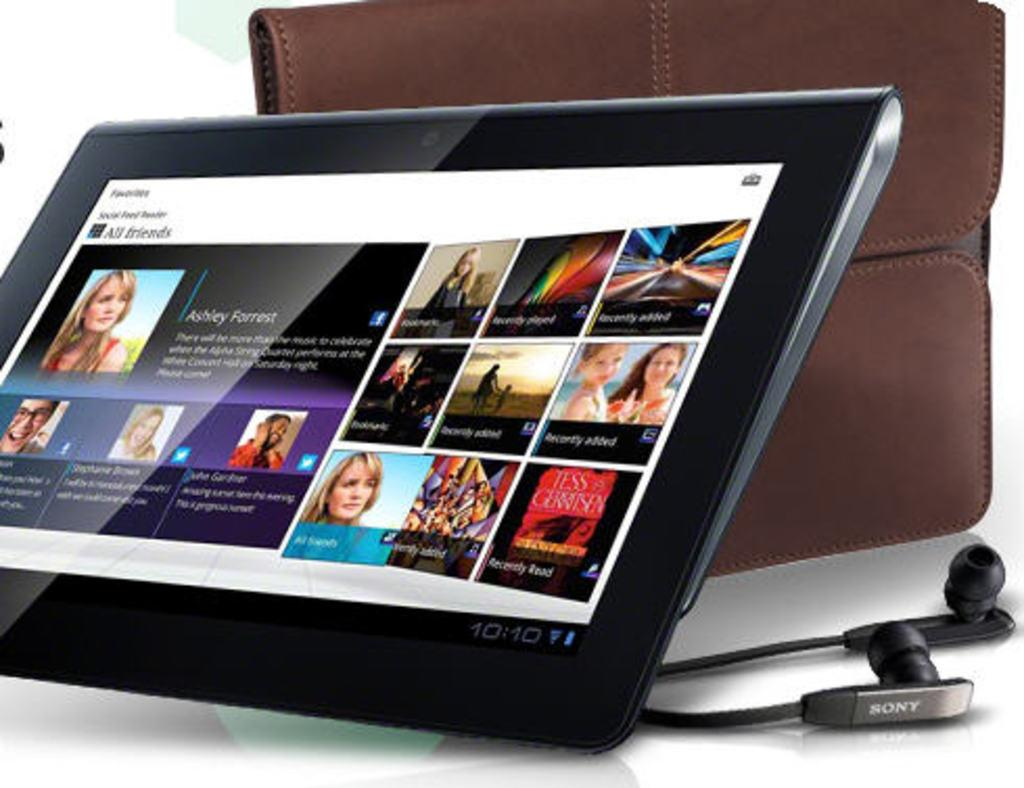What is displayed on the tab in the image? There are pictures and text on a tab in the image. What items are on the table in the image? There are headphones and a wallet on the table in the image. How many bikes are parked next to the table in the image? There are no bikes present in the image. What type of pancake is being served on the table in the image? There is no pancake present in the image. 